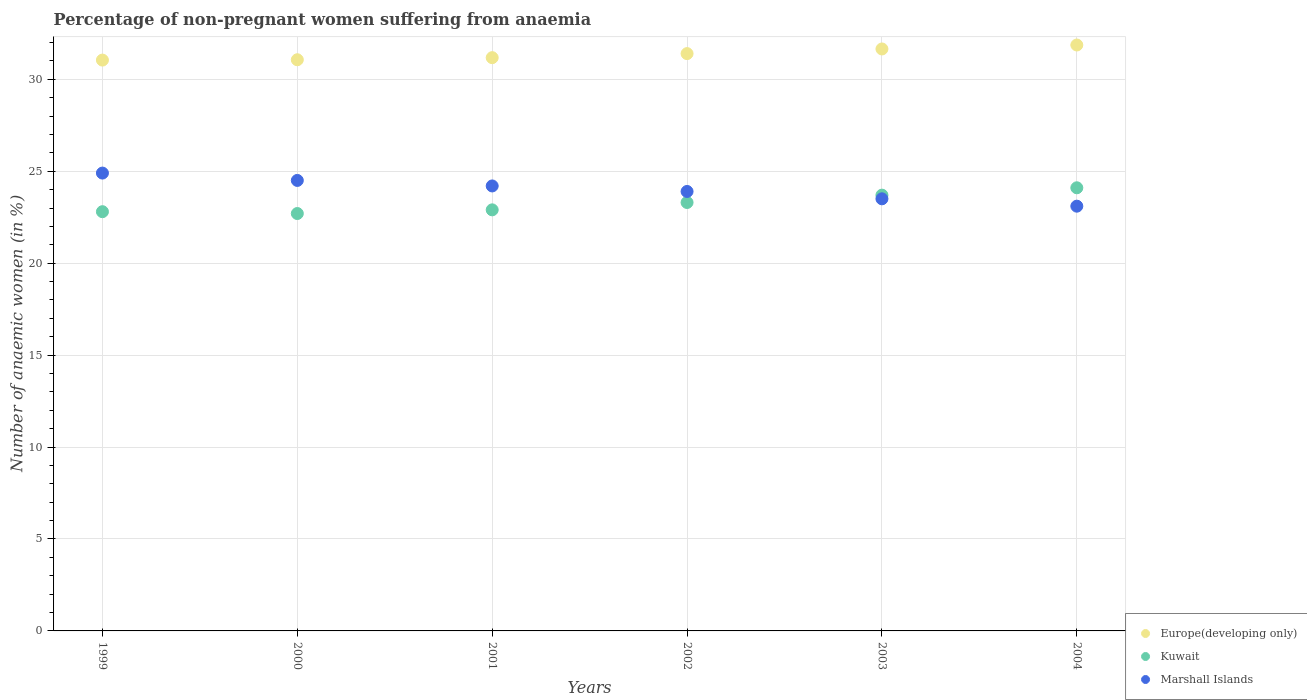How many different coloured dotlines are there?
Keep it short and to the point. 3. What is the percentage of non-pregnant women suffering from anaemia in Marshall Islands in 2004?
Give a very brief answer. 23.1. Across all years, what is the maximum percentage of non-pregnant women suffering from anaemia in Marshall Islands?
Ensure brevity in your answer.  24.9. Across all years, what is the minimum percentage of non-pregnant women suffering from anaemia in Europe(developing only)?
Offer a terse response. 31.04. In which year was the percentage of non-pregnant women suffering from anaemia in Marshall Islands maximum?
Keep it short and to the point. 1999. What is the total percentage of non-pregnant women suffering from anaemia in Europe(developing only) in the graph?
Provide a succinct answer. 188.2. What is the difference between the percentage of non-pregnant women suffering from anaemia in Marshall Islands in 2000 and that in 2004?
Give a very brief answer. 1.4. What is the difference between the percentage of non-pregnant women suffering from anaemia in Europe(developing only) in 2003 and the percentage of non-pregnant women suffering from anaemia in Marshall Islands in 1999?
Your answer should be compact. 6.75. What is the average percentage of non-pregnant women suffering from anaemia in Europe(developing only) per year?
Keep it short and to the point. 31.37. In the year 2002, what is the difference between the percentage of non-pregnant women suffering from anaemia in Europe(developing only) and percentage of non-pregnant women suffering from anaemia in Marshall Islands?
Offer a very short reply. 7.5. In how many years, is the percentage of non-pregnant women suffering from anaemia in Europe(developing only) greater than 8 %?
Provide a short and direct response. 6. What is the ratio of the percentage of non-pregnant women suffering from anaemia in Europe(developing only) in 1999 to that in 2003?
Ensure brevity in your answer.  0.98. Is the difference between the percentage of non-pregnant women suffering from anaemia in Europe(developing only) in 2001 and 2002 greater than the difference between the percentage of non-pregnant women suffering from anaemia in Marshall Islands in 2001 and 2002?
Offer a very short reply. No. What is the difference between the highest and the second highest percentage of non-pregnant women suffering from anaemia in Kuwait?
Give a very brief answer. 0.4. What is the difference between the highest and the lowest percentage of non-pregnant women suffering from anaemia in Marshall Islands?
Give a very brief answer. 1.8. In how many years, is the percentage of non-pregnant women suffering from anaemia in Marshall Islands greater than the average percentage of non-pregnant women suffering from anaemia in Marshall Islands taken over all years?
Keep it short and to the point. 3. Does the percentage of non-pregnant women suffering from anaemia in Kuwait monotonically increase over the years?
Provide a short and direct response. No. Is the percentage of non-pregnant women suffering from anaemia in Europe(developing only) strictly greater than the percentage of non-pregnant women suffering from anaemia in Kuwait over the years?
Offer a very short reply. Yes. Is the percentage of non-pregnant women suffering from anaemia in Kuwait strictly less than the percentage of non-pregnant women suffering from anaemia in Europe(developing only) over the years?
Your answer should be very brief. Yes. How many dotlines are there?
Give a very brief answer. 3. How many years are there in the graph?
Ensure brevity in your answer.  6. What is the difference between two consecutive major ticks on the Y-axis?
Offer a terse response. 5. Does the graph contain any zero values?
Provide a short and direct response. No. Does the graph contain grids?
Make the answer very short. Yes. Where does the legend appear in the graph?
Provide a succinct answer. Bottom right. What is the title of the graph?
Offer a very short reply. Percentage of non-pregnant women suffering from anaemia. What is the label or title of the X-axis?
Your answer should be compact. Years. What is the label or title of the Y-axis?
Your answer should be very brief. Number of anaemic women (in %). What is the Number of anaemic women (in %) in Europe(developing only) in 1999?
Your response must be concise. 31.04. What is the Number of anaemic women (in %) of Kuwait in 1999?
Keep it short and to the point. 22.8. What is the Number of anaemic women (in %) of Marshall Islands in 1999?
Offer a very short reply. 24.9. What is the Number of anaemic women (in %) in Europe(developing only) in 2000?
Give a very brief answer. 31.06. What is the Number of anaemic women (in %) in Kuwait in 2000?
Give a very brief answer. 22.7. What is the Number of anaemic women (in %) in Europe(developing only) in 2001?
Provide a short and direct response. 31.18. What is the Number of anaemic women (in %) in Kuwait in 2001?
Your answer should be very brief. 22.9. What is the Number of anaemic women (in %) of Marshall Islands in 2001?
Your response must be concise. 24.2. What is the Number of anaemic women (in %) of Europe(developing only) in 2002?
Keep it short and to the point. 31.4. What is the Number of anaemic women (in %) of Kuwait in 2002?
Your answer should be compact. 23.3. What is the Number of anaemic women (in %) of Marshall Islands in 2002?
Give a very brief answer. 23.9. What is the Number of anaemic women (in %) of Europe(developing only) in 2003?
Offer a terse response. 31.65. What is the Number of anaemic women (in %) of Kuwait in 2003?
Your answer should be very brief. 23.7. What is the Number of anaemic women (in %) of Marshall Islands in 2003?
Make the answer very short. 23.5. What is the Number of anaemic women (in %) in Europe(developing only) in 2004?
Your response must be concise. 31.87. What is the Number of anaemic women (in %) in Kuwait in 2004?
Provide a succinct answer. 24.1. What is the Number of anaemic women (in %) of Marshall Islands in 2004?
Offer a terse response. 23.1. Across all years, what is the maximum Number of anaemic women (in %) of Europe(developing only)?
Make the answer very short. 31.87. Across all years, what is the maximum Number of anaemic women (in %) in Kuwait?
Offer a terse response. 24.1. Across all years, what is the maximum Number of anaemic women (in %) of Marshall Islands?
Offer a very short reply. 24.9. Across all years, what is the minimum Number of anaemic women (in %) of Europe(developing only)?
Offer a very short reply. 31.04. Across all years, what is the minimum Number of anaemic women (in %) of Kuwait?
Your response must be concise. 22.7. Across all years, what is the minimum Number of anaemic women (in %) in Marshall Islands?
Provide a short and direct response. 23.1. What is the total Number of anaemic women (in %) of Europe(developing only) in the graph?
Offer a very short reply. 188.2. What is the total Number of anaemic women (in %) of Kuwait in the graph?
Your response must be concise. 139.5. What is the total Number of anaemic women (in %) in Marshall Islands in the graph?
Your answer should be very brief. 144.1. What is the difference between the Number of anaemic women (in %) of Europe(developing only) in 1999 and that in 2000?
Offer a terse response. -0.02. What is the difference between the Number of anaemic women (in %) in Kuwait in 1999 and that in 2000?
Your answer should be very brief. 0.1. What is the difference between the Number of anaemic women (in %) of Marshall Islands in 1999 and that in 2000?
Offer a terse response. 0.4. What is the difference between the Number of anaemic women (in %) in Europe(developing only) in 1999 and that in 2001?
Your answer should be very brief. -0.13. What is the difference between the Number of anaemic women (in %) of Kuwait in 1999 and that in 2001?
Your answer should be compact. -0.1. What is the difference between the Number of anaemic women (in %) in Marshall Islands in 1999 and that in 2001?
Ensure brevity in your answer.  0.7. What is the difference between the Number of anaemic women (in %) in Europe(developing only) in 1999 and that in 2002?
Your response must be concise. -0.35. What is the difference between the Number of anaemic women (in %) of Marshall Islands in 1999 and that in 2002?
Provide a short and direct response. 1. What is the difference between the Number of anaemic women (in %) of Europe(developing only) in 1999 and that in 2003?
Provide a short and direct response. -0.6. What is the difference between the Number of anaemic women (in %) of Kuwait in 1999 and that in 2003?
Offer a terse response. -0.9. What is the difference between the Number of anaemic women (in %) in Marshall Islands in 1999 and that in 2003?
Provide a short and direct response. 1.4. What is the difference between the Number of anaemic women (in %) in Europe(developing only) in 1999 and that in 2004?
Provide a succinct answer. -0.82. What is the difference between the Number of anaemic women (in %) of Kuwait in 1999 and that in 2004?
Offer a very short reply. -1.3. What is the difference between the Number of anaemic women (in %) in Europe(developing only) in 2000 and that in 2001?
Make the answer very short. -0.11. What is the difference between the Number of anaemic women (in %) of Europe(developing only) in 2000 and that in 2002?
Your answer should be compact. -0.33. What is the difference between the Number of anaemic women (in %) of Marshall Islands in 2000 and that in 2002?
Offer a terse response. 0.6. What is the difference between the Number of anaemic women (in %) of Europe(developing only) in 2000 and that in 2003?
Your answer should be very brief. -0.59. What is the difference between the Number of anaemic women (in %) of Kuwait in 2000 and that in 2003?
Make the answer very short. -1. What is the difference between the Number of anaemic women (in %) of Europe(developing only) in 2000 and that in 2004?
Give a very brief answer. -0.8. What is the difference between the Number of anaemic women (in %) in Marshall Islands in 2000 and that in 2004?
Your answer should be compact. 1.4. What is the difference between the Number of anaemic women (in %) in Europe(developing only) in 2001 and that in 2002?
Give a very brief answer. -0.22. What is the difference between the Number of anaemic women (in %) of Europe(developing only) in 2001 and that in 2003?
Ensure brevity in your answer.  -0.47. What is the difference between the Number of anaemic women (in %) in Kuwait in 2001 and that in 2003?
Keep it short and to the point. -0.8. What is the difference between the Number of anaemic women (in %) in Europe(developing only) in 2001 and that in 2004?
Keep it short and to the point. -0.69. What is the difference between the Number of anaemic women (in %) of Marshall Islands in 2001 and that in 2004?
Your answer should be compact. 1.1. What is the difference between the Number of anaemic women (in %) in Europe(developing only) in 2002 and that in 2003?
Keep it short and to the point. -0.25. What is the difference between the Number of anaemic women (in %) of Marshall Islands in 2002 and that in 2003?
Provide a succinct answer. 0.4. What is the difference between the Number of anaemic women (in %) in Europe(developing only) in 2002 and that in 2004?
Your response must be concise. -0.47. What is the difference between the Number of anaemic women (in %) of Kuwait in 2002 and that in 2004?
Offer a terse response. -0.8. What is the difference between the Number of anaemic women (in %) of Marshall Islands in 2002 and that in 2004?
Provide a succinct answer. 0.8. What is the difference between the Number of anaemic women (in %) of Europe(developing only) in 2003 and that in 2004?
Offer a very short reply. -0.22. What is the difference between the Number of anaemic women (in %) of Europe(developing only) in 1999 and the Number of anaemic women (in %) of Kuwait in 2000?
Your answer should be compact. 8.34. What is the difference between the Number of anaemic women (in %) of Europe(developing only) in 1999 and the Number of anaemic women (in %) of Marshall Islands in 2000?
Your answer should be compact. 6.54. What is the difference between the Number of anaemic women (in %) in Kuwait in 1999 and the Number of anaemic women (in %) in Marshall Islands in 2000?
Provide a succinct answer. -1.7. What is the difference between the Number of anaemic women (in %) in Europe(developing only) in 1999 and the Number of anaemic women (in %) in Kuwait in 2001?
Provide a short and direct response. 8.14. What is the difference between the Number of anaemic women (in %) of Europe(developing only) in 1999 and the Number of anaemic women (in %) of Marshall Islands in 2001?
Ensure brevity in your answer.  6.84. What is the difference between the Number of anaemic women (in %) in Kuwait in 1999 and the Number of anaemic women (in %) in Marshall Islands in 2001?
Your answer should be compact. -1.4. What is the difference between the Number of anaemic women (in %) of Europe(developing only) in 1999 and the Number of anaemic women (in %) of Kuwait in 2002?
Provide a succinct answer. 7.74. What is the difference between the Number of anaemic women (in %) in Europe(developing only) in 1999 and the Number of anaemic women (in %) in Marshall Islands in 2002?
Offer a very short reply. 7.14. What is the difference between the Number of anaemic women (in %) of Europe(developing only) in 1999 and the Number of anaemic women (in %) of Kuwait in 2003?
Offer a very short reply. 7.34. What is the difference between the Number of anaemic women (in %) in Europe(developing only) in 1999 and the Number of anaemic women (in %) in Marshall Islands in 2003?
Ensure brevity in your answer.  7.54. What is the difference between the Number of anaemic women (in %) in Europe(developing only) in 1999 and the Number of anaemic women (in %) in Kuwait in 2004?
Ensure brevity in your answer.  6.94. What is the difference between the Number of anaemic women (in %) of Europe(developing only) in 1999 and the Number of anaemic women (in %) of Marshall Islands in 2004?
Ensure brevity in your answer.  7.94. What is the difference between the Number of anaemic women (in %) of Kuwait in 1999 and the Number of anaemic women (in %) of Marshall Islands in 2004?
Ensure brevity in your answer.  -0.3. What is the difference between the Number of anaemic women (in %) in Europe(developing only) in 2000 and the Number of anaemic women (in %) in Kuwait in 2001?
Your answer should be compact. 8.16. What is the difference between the Number of anaemic women (in %) in Europe(developing only) in 2000 and the Number of anaemic women (in %) in Marshall Islands in 2001?
Your answer should be compact. 6.86. What is the difference between the Number of anaemic women (in %) of Europe(developing only) in 2000 and the Number of anaemic women (in %) of Kuwait in 2002?
Provide a succinct answer. 7.76. What is the difference between the Number of anaemic women (in %) of Europe(developing only) in 2000 and the Number of anaemic women (in %) of Marshall Islands in 2002?
Make the answer very short. 7.16. What is the difference between the Number of anaemic women (in %) in Kuwait in 2000 and the Number of anaemic women (in %) in Marshall Islands in 2002?
Your answer should be very brief. -1.2. What is the difference between the Number of anaemic women (in %) of Europe(developing only) in 2000 and the Number of anaemic women (in %) of Kuwait in 2003?
Give a very brief answer. 7.36. What is the difference between the Number of anaemic women (in %) of Europe(developing only) in 2000 and the Number of anaemic women (in %) of Marshall Islands in 2003?
Your answer should be very brief. 7.56. What is the difference between the Number of anaemic women (in %) of Europe(developing only) in 2000 and the Number of anaemic women (in %) of Kuwait in 2004?
Your answer should be compact. 6.96. What is the difference between the Number of anaemic women (in %) of Europe(developing only) in 2000 and the Number of anaemic women (in %) of Marshall Islands in 2004?
Offer a terse response. 7.96. What is the difference between the Number of anaemic women (in %) of Europe(developing only) in 2001 and the Number of anaemic women (in %) of Kuwait in 2002?
Offer a terse response. 7.88. What is the difference between the Number of anaemic women (in %) of Europe(developing only) in 2001 and the Number of anaemic women (in %) of Marshall Islands in 2002?
Provide a succinct answer. 7.28. What is the difference between the Number of anaemic women (in %) in Europe(developing only) in 2001 and the Number of anaemic women (in %) in Kuwait in 2003?
Provide a succinct answer. 7.48. What is the difference between the Number of anaemic women (in %) of Europe(developing only) in 2001 and the Number of anaemic women (in %) of Marshall Islands in 2003?
Offer a terse response. 7.68. What is the difference between the Number of anaemic women (in %) of Europe(developing only) in 2001 and the Number of anaemic women (in %) of Kuwait in 2004?
Your answer should be very brief. 7.08. What is the difference between the Number of anaemic women (in %) in Europe(developing only) in 2001 and the Number of anaemic women (in %) in Marshall Islands in 2004?
Ensure brevity in your answer.  8.08. What is the difference between the Number of anaemic women (in %) in Kuwait in 2001 and the Number of anaemic women (in %) in Marshall Islands in 2004?
Ensure brevity in your answer.  -0.2. What is the difference between the Number of anaemic women (in %) in Europe(developing only) in 2002 and the Number of anaemic women (in %) in Kuwait in 2003?
Provide a short and direct response. 7.7. What is the difference between the Number of anaemic women (in %) of Europe(developing only) in 2002 and the Number of anaemic women (in %) of Marshall Islands in 2003?
Ensure brevity in your answer.  7.9. What is the difference between the Number of anaemic women (in %) of Europe(developing only) in 2002 and the Number of anaemic women (in %) of Kuwait in 2004?
Offer a very short reply. 7.3. What is the difference between the Number of anaemic women (in %) in Europe(developing only) in 2002 and the Number of anaemic women (in %) in Marshall Islands in 2004?
Give a very brief answer. 8.3. What is the difference between the Number of anaemic women (in %) in Kuwait in 2002 and the Number of anaemic women (in %) in Marshall Islands in 2004?
Your answer should be compact. 0.2. What is the difference between the Number of anaemic women (in %) of Europe(developing only) in 2003 and the Number of anaemic women (in %) of Kuwait in 2004?
Give a very brief answer. 7.55. What is the difference between the Number of anaemic women (in %) of Europe(developing only) in 2003 and the Number of anaemic women (in %) of Marshall Islands in 2004?
Ensure brevity in your answer.  8.55. What is the difference between the Number of anaemic women (in %) of Kuwait in 2003 and the Number of anaemic women (in %) of Marshall Islands in 2004?
Offer a terse response. 0.6. What is the average Number of anaemic women (in %) in Europe(developing only) per year?
Ensure brevity in your answer.  31.37. What is the average Number of anaemic women (in %) of Kuwait per year?
Give a very brief answer. 23.25. What is the average Number of anaemic women (in %) of Marshall Islands per year?
Provide a short and direct response. 24.02. In the year 1999, what is the difference between the Number of anaemic women (in %) in Europe(developing only) and Number of anaemic women (in %) in Kuwait?
Offer a very short reply. 8.24. In the year 1999, what is the difference between the Number of anaemic women (in %) in Europe(developing only) and Number of anaemic women (in %) in Marshall Islands?
Make the answer very short. 6.14. In the year 1999, what is the difference between the Number of anaemic women (in %) of Kuwait and Number of anaemic women (in %) of Marshall Islands?
Provide a short and direct response. -2.1. In the year 2000, what is the difference between the Number of anaemic women (in %) of Europe(developing only) and Number of anaemic women (in %) of Kuwait?
Your response must be concise. 8.36. In the year 2000, what is the difference between the Number of anaemic women (in %) of Europe(developing only) and Number of anaemic women (in %) of Marshall Islands?
Provide a succinct answer. 6.56. In the year 2000, what is the difference between the Number of anaemic women (in %) of Kuwait and Number of anaemic women (in %) of Marshall Islands?
Your response must be concise. -1.8. In the year 2001, what is the difference between the Number of anaemic women (in %) of Europe(developing only) and Number of anaemic women (in %) of Kuwait?
Your answer should be compact. 8.28. In the year 2001, what is the difference between the Number of anaemic women (in %) in Europe(developing only) and Number of anaemic women (in %) in Marshall Islands?
Offer a terse response. 6.98. In the year 2002, what is the difference between the Number of anaemic women (in %) in Europe(developing only) and Number of anaemic women (in %) in Kuwait?
Make the answer very short. 8.1. In the year 2002, what is the difference between the Number of anaemic women (in %) of Europe(developing only) and Number of anaemic women (in %) of Marshall Islands?
Your response must be concise. 7.5. In the year 2003, what is the difference between the Number of anaemic women (in %) of Europe(developing only) and Number of anaemic women (in %) of Kuwait?
Your response must be concise. 7.95. In the year 2003, what is the difference between the Number of anaemic women (in %) of Europe(developing only) and Number of anaemic women (in %) of Marshall Islands?
Provide a short and direct response. 8.15. In the year 2004, what is the difference between the Number of anaemic women (in %) of Europe(developing only) and Number of anaemic women (in %) of Kuwait?
Make the answer very short. 7.77. In the year 2004, what is the difference between the Number of anaemic women (in %) in Europe(developing only) and Number of anaemic women (in %) in Marshall Islands?
Make the answer very short. 8.77. What is the ratio of the Number of anaemic women (in %) of Kuwait in 1999 to that in 2000?
Your answer should be very brief. 1. What is the ratio of the Number of anaemic women (in %) in Marshall Islands in 1999 to that in 2000?
Offer a very short reply. 1.02. What is the ratio of the Number of anaemic women (in %) in Europe(developing only) in 1999 to that in 2001?
Your answer should be compact. 1. What is the ratio of the Number of anaemic women (in %) of Marshall Islands in 1999 to that in 2001?
Give a very brief answer. 1.03. What is the ratio of the Number of anaemic women (in %) in Europe(developing only) in 1999 to that in 2002?
Offer a terse response. 0.99. What is the ratio of the Number of anaemic women (in %) of Kuwait in 1999 to that in 2002?
Give a very brief answer. 0.98. What is the ratio of the Number of anaemic women (in %) of Marshall Islands in 1999 to that in 2002?
Ensure brevity in your answer.  1.04. What is the ratio of the Number of anaemic women (in %) in Europe(developing only) in 1999 to that in 2003?
Provide a short and direct response. 0.98. What is the ratio of the Number of anaemic women (in %) in Marshall Islands in 1999 to that in 2003?
Provide a short and direct response. 1.06. What is the ratio of the Number of anaemic women (in %) of Europe(developing only) in 1999 to that in 2004?
Make the answer very short. 0.97. What is the ratio of the Number of anaemic women (in %) in Kuwait in 1999 to that in 2004?
Ensure brevity in your answer.  0.95. What is the ratio of the Number of anaemic women (in %) in Marshall Islands in 1999 to that in 2004?
Ensure brevity in your answer.  1.08. What is the ratio of the Number of anaemic women (in %) in Marshall Islands in 2000 to that in 2001?
Offer a terse response. 1.01. What is the ratio of the Number of anaemic women (in %) of Kuwait in 2000 to that in 2002?
Give a very brief answer. 0.97. What is the ratio of the Number of anaemic women (in %) in Marshall Islands in 2000 to that in 2002?
Keep it short and to the point. 1.03. What is the ratio of the Number of anaemic women (in %) of Europe(developing only) in 2000 to that in 2003?
Provide a succinct answer. 0.98. What is the ratio of the Number of anaemic women (in %) of Kuwait in 2000 to that in 2003?
Keep it short and to the point. 0.96. What is the ratio of the Number of anaemic women (in %) of Marshall Islands in 2000 to that in 2003?
Provide a short and direct response. 1.04. What is the ratio of the Number of anaemic women (in %) in Europe(developing only) in 2000 to that in 2004?
Offer a very short reply. 0.97. What is the ratio of the Number of anaemic women (in %) of Kuwait in 2000 to that in 2004?
Provide a short and direct response. 0.94. What is the ratio of the Number of anaemic women (in %) in Marshall Islands in 2000 to that in 2004?
Offer a terse response. 1.06. What is the ratio of the Number of anaemic women (in %) in Kuwait in 2001 to that in 2002?
Provide a succinct answer. 0.98. What is the ratio of the Number of anaemic women (in %) of Marshall Islands in 2001 to that in 2002?
Keep it short and to the point. 1.01. What is the ratio of the Number of anaemic women (in %) in Europe(developing only) in 2001 to that in 2003?
Offer a terse response. 0.99. What is the ratio of the Number of anaemic women (in %) of Kuwait in 2001 to that in 2003?
Keep it short and to the point. 0.97. What is the ratio of the Number of anaemic women (in %) of Marshall Islands in 2001 to that in 2003?
Ensure brevity in your answer.  1.03. What is the ratio of the Number of anaemic women (in %) in Europe(developing only) in 2001 to that in 2004?
Make the answer very short. 0.98. What is the ratio of the Number of anaemic women (in %) in Kuwait in 2001 to that in 2004?
Make the answer very short. 0.95. What is the ratio of the Number of anaemic women (in %) in Marshall Islands in 2001 to that in 2004?
Keep it short and to the point. 1.05. What is the ratio of the Number of anaemic women (in %) in Kuwait in 2002 to that in 2003?
Provide a short and direct response. 0.98. What is the ratio of the Number of anaemic women (in %) of Kuwait in 2002 to that in 2004?
Your answer should be compact. 0.97. What is the ratio of the Number of anaemic women (in %) of Marshall Islands in 2002 to that in 2004?
Offer a very short reply. 1.03. What is the ratio of the Number of anaemic women (in %) of Kuwait in 2003 to that in 2004?
Provide a short and direct response. 0.98. What is the ratio of the Number of anaemic women (in %) in Marshall Islands in 2003 to that in 2004?
Provide a short and direct response. 1.02. What is the difference between the highest and the second highest Number of anaemic women (in %) of Europe(developing only)?
Provide a succinct answer. 0.22. What is the difference between the highest and the second highest Number of anaemic women (in %) of Kuwait?
Provide a short and direct response. 0.4. What is the difference between the highest and the lowest Number of anaemic women (in %) of Europe(developing only)?
Provide a succinct answer. 0.82. What is the difference between the highest and the lowest Number of anaemic women (in %) in Kuwait?
Make the answer very short. 1.4. What is the difference between the highest and the lowest Number of anaemic women (in %) in Marshall Islands?
Your answer should be compact. 1.8. 